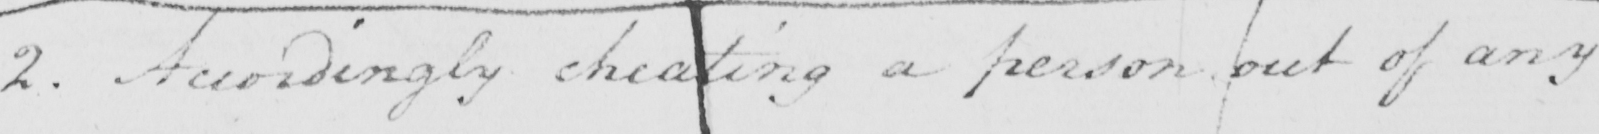What text is written in this handwritten line? 2 . Accordingly cheating a person out of any 